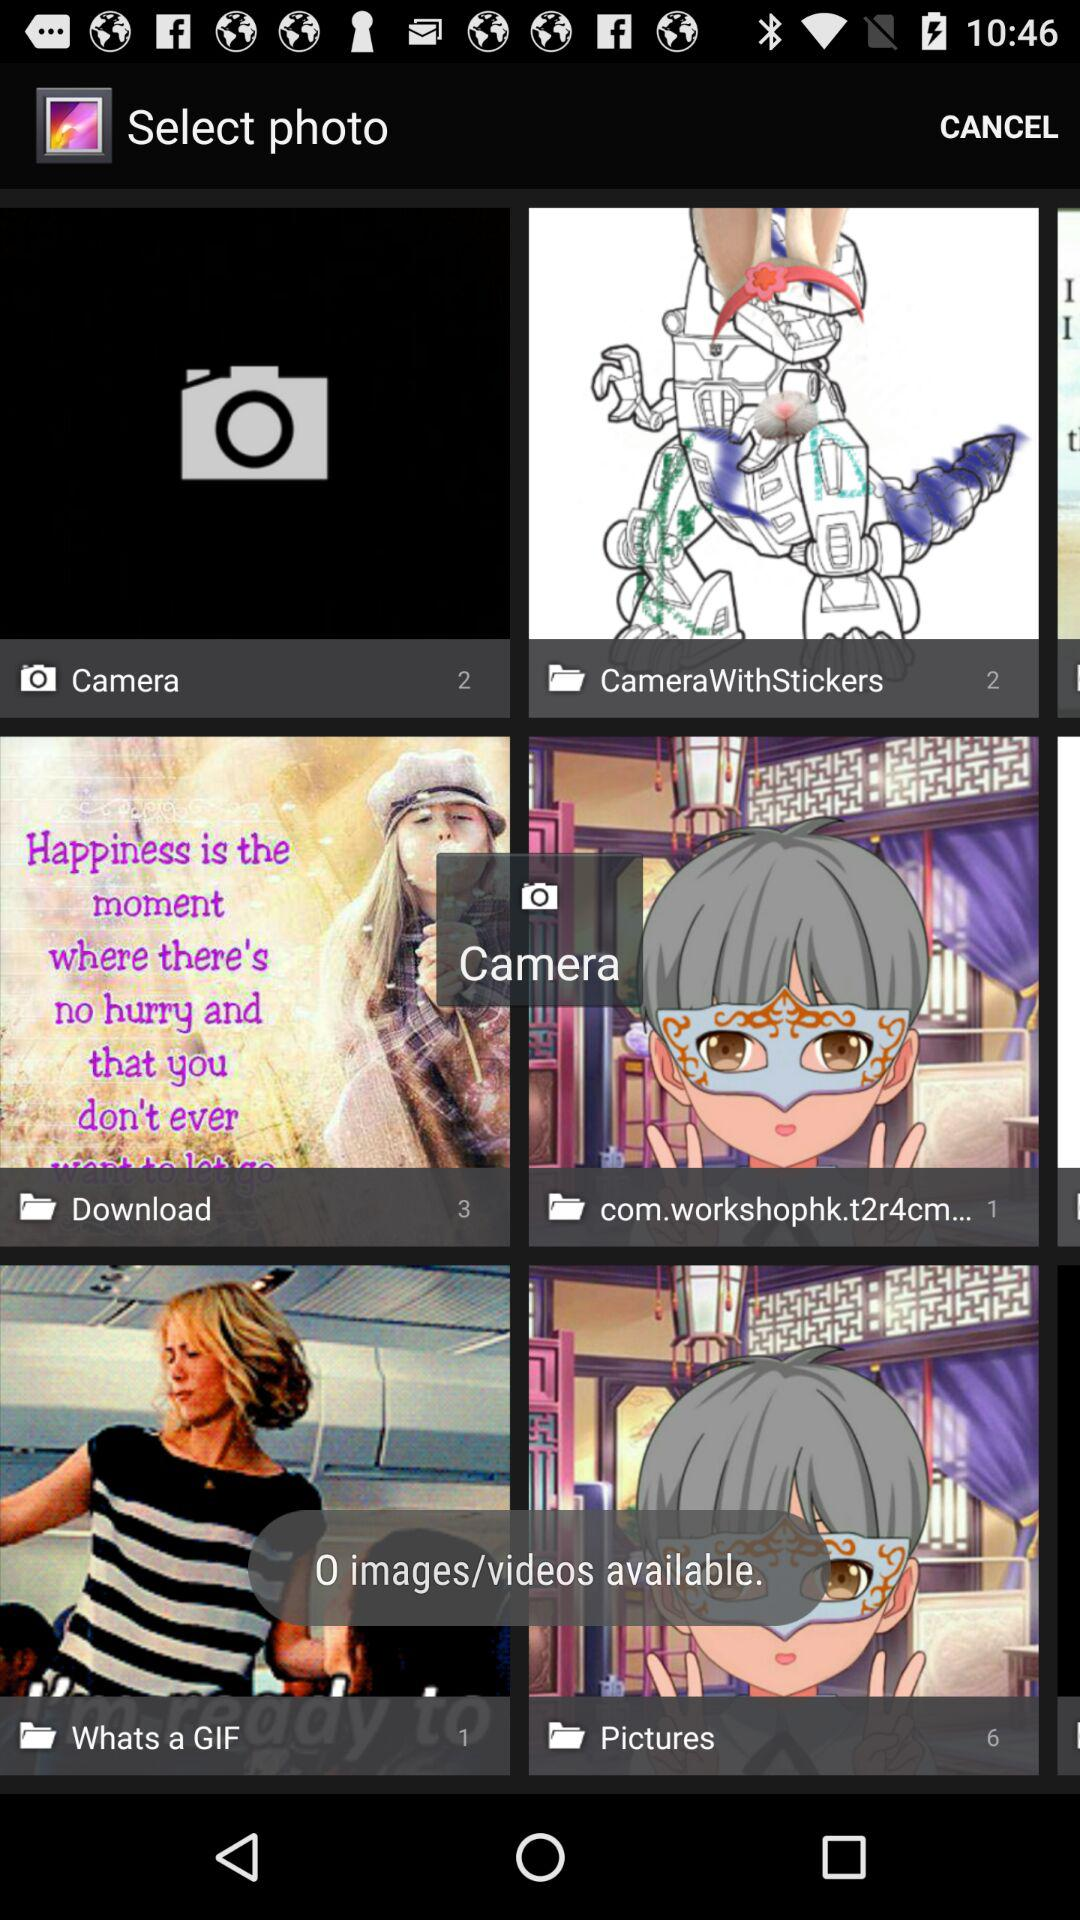What is the number of photos in "CameraWithStickers"? The number of photos in "CameraWithStickers" is 2. 